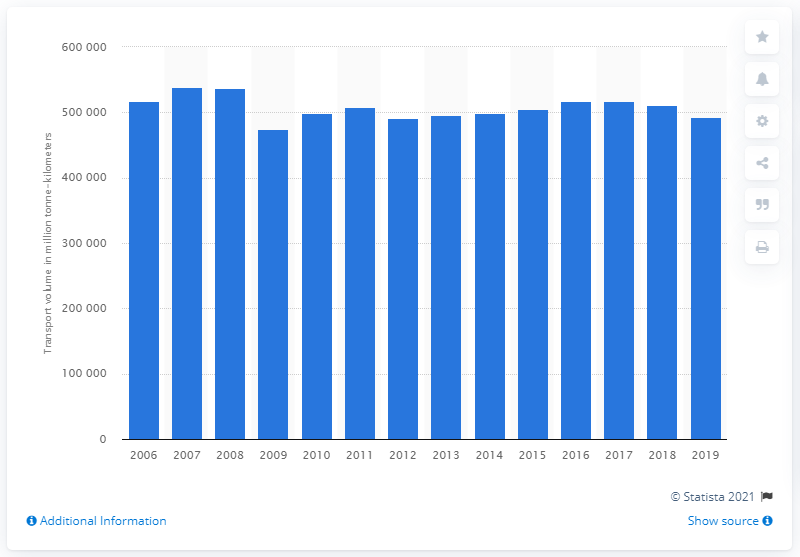Highlight a few significant elements in this photo. In Germany, the amount of freight transported between 2006 and 2019 was approximately 493,577. 